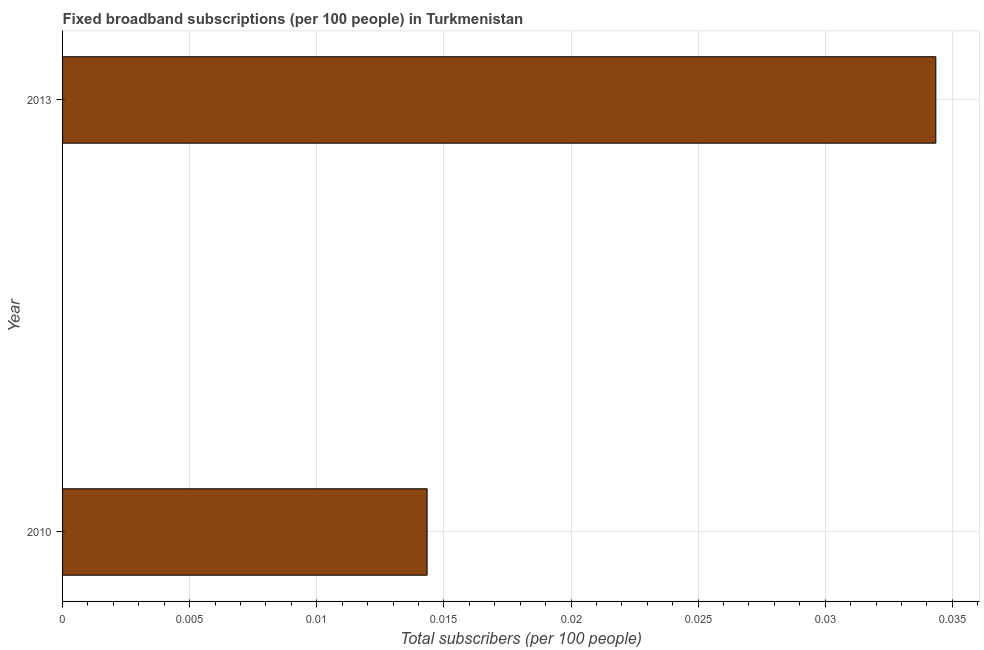Does the graph contain grids?
Your response must be concise. Yes. What is the title of the graph?
Provide a short and direct response. Fixed broadband subscriptions (per 100 people) in Turkmenistan. What is the label or title of the X-axis?
Give a very brief answer. Total subscribers (per 100 people). What is the label or title of the Y-axis?
Give a very brief answer. Year. What is the total number of fixed broadband subscriptions in 2010?
Your response must be concise. 0.01. Across all years, what is the maximum total number of fixed broadband subscriptions?
Keep it short and to the point. 0.03. Across all years, what is the minimum total number of fixed broadband subscriptions?
Ensure brevity in your answer.  0.01. What is the sum of the total number of fixed broadband subscriptions?
Offer a very short reply. 0.05. What is the difference between the total number of fixed broadband subscriptions in 2010 and 2013?
Give a very brief answer. -0.02. What is the average total number of fixed broadband subscriptions per year?
Provide a short and direct response. 0.02. What is the median total number of fixed broadband subscriptions?
Ensure brevity in your answer.  0.02. In how many years, is the total number of fixed broadband subscriptions greater than 0.023 ?
Ensure brevity in your answer.  1. What is the ratio of the total number of fixed broadband subscriptions in 2010 to that in 2013?
Your answer should be very brief. 0.42. Is the total number of fixed broadband subscriptions in 2010 less than that in 2013?
Your response must be concise. Yes. In how many years, is the total number of fixed broadband subscriptions greater than the average total number of fixed broadband subscriptions taken over all years?
Your response must be concise. 1. How many bars are there?
Offer a very short reply. 2. How many years are there in the graph?
Your answer should be very brief. 2. What is the difference between two consecutive major ticks on the X-axis?
Make the answer very short. 0.01. Are the values on the major ticks of X-axis written in scientific E-notation?
Provide a succinct answer. No. What is the Total subscribers (per 100 people) of 2010?
Give a very brief answer. 0.01. What is the Total subscribers (per 100 people) of 2013?
Your answer should be compact. 0.03. What is the difference between the Total subscribers (per 100 people) in 2010 and 2013?
Provide a succinct answer. -0.02. What is the ratio of the Total subscribers (per 100 people) in 2010 to that in 2013?
Offer a very short reply. 0.42. 